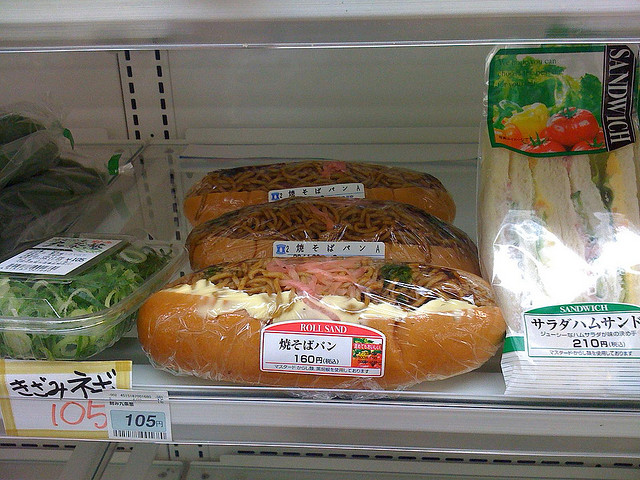<image>How much do the onions cost? I don't know how much the onions cost. It can be 105 yen or 210 yen. How much do the onions cost? The onions cost 105 yen. 